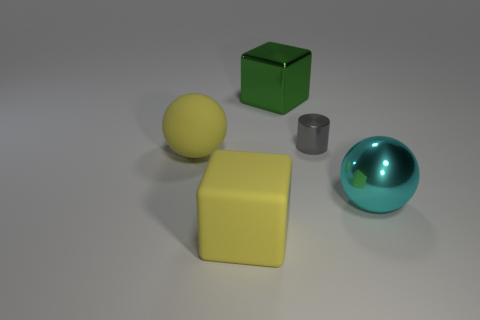What number of yellow objects have the same size as the gray cylinder?
Your answer should be very brief. 0. Does the thing that is to the left of the yellow rubber cube have the same size as the object that is on the right side of the gray metal cylinder?
Your answer should be compact. Yes. What shape is the small gray object in front of the large green metallic block?
Provide a succinct answer. Cylinder. What is the material of the sphere that is on the left side of the object that is behind the tiny shiny thing?
Your response must be concise. Rubber. Is there a rubber cube of the same color as the rubber sphere?
Ensure brevity in your answer.  Yes. Does the gray metallic cylinder have the same size as the sphere that is left of the cylinder?
Keep it short and to the point. No. There is a big block that is in front of the big metallic thing that is behind the large matte sphere; how many cyan objects are on the left side of it?
Your response must be concise. 0. There is a large green metal object; how many big shiny things are behind it?
Provide a succinct answer. 0. There is a large metal object to the right of the large shiny thing that is behind the large metallic sphere; what color is it?
Provide a succinct answer. Cyan. What number of other things are there of the same material as the large green object
Ensure brevity in your answer.  2. 